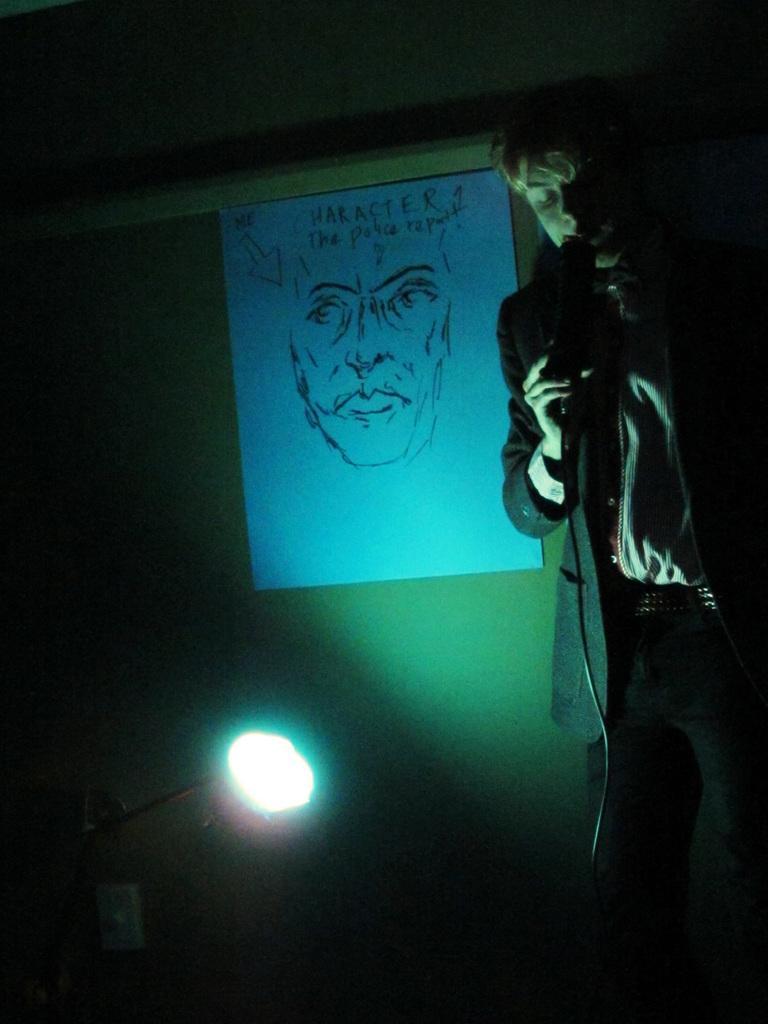Can you describe this image briefly? In the foreground of this image, on the right, there is a man standing and holding a mic. On the left bottom, there is a light. In the background, there is a poster on the wall. On the top, there is the ceiling. 